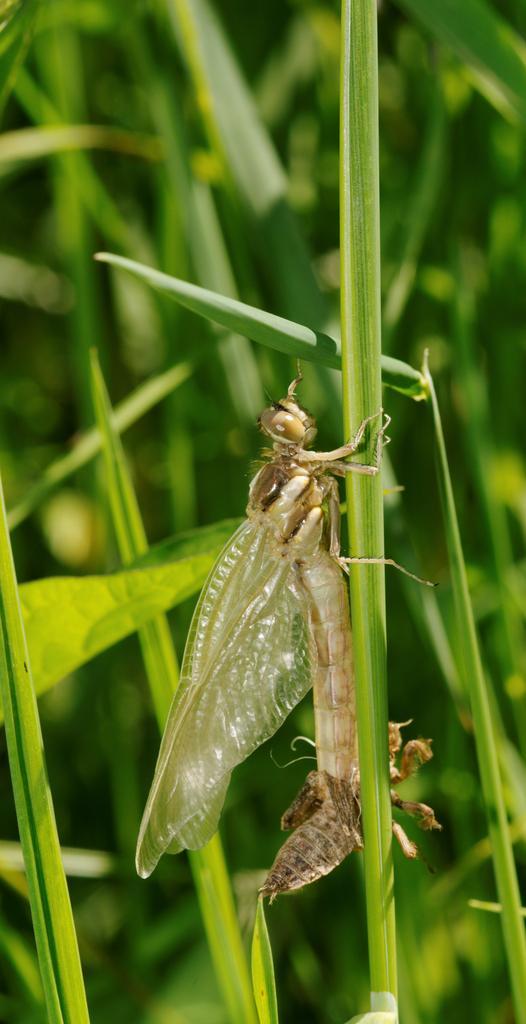Could you give a brief overview of what you see in this image? In this image I can see an insect on the grass and the grass is in green color. 